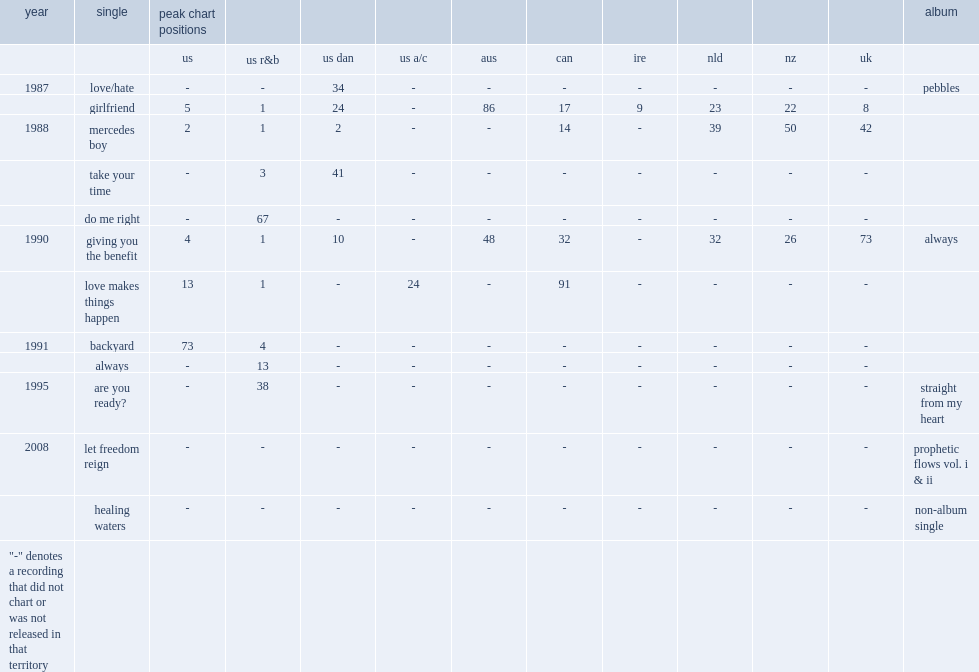When did the single always release? 1991.0. 